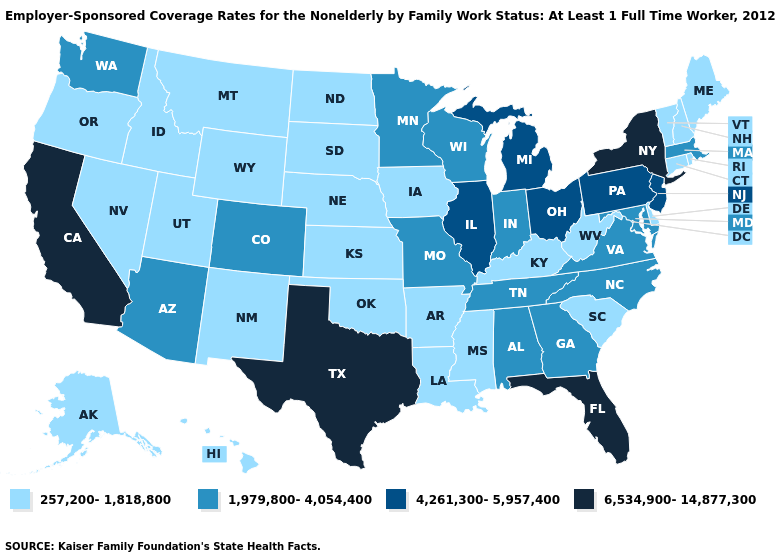Does Hawaii have the lowest value in the USA?
Give a very brief answer. Yes. Does Pennsylvania have the lowest value in the USA?
Be succinct. No. Does Florida have the lowest value in the USA?
Short answer required. No. Name the states that have a value in the range 6,534,900-14,877,300?
Answer briefly. California, Florida, New York, Texas. What is the lowest value in states that border West Virginia?
Short answer required. 257,200-1,818,800. Does the map have missing data?
Short answer required. No. What is the value of Arkansas?
Concise answer only. 257,200-1,818,800. What is the highest value in the Northeast ?
Be succinct. 6,534,900-14,877,300. Is the legend a continuous bar?
Short answer required. No. What is the value of Kansas?
Concise answer only. 257,200-1,818,800. Does Iowa have the lowest value in the MidWest?
Short answer required. Yes. Which states have the lowest value in the South?
Be succinct. Arkansas, Delaware, Kentucky, Louisiana, Mississippi, Oklahoma, South Carolina, West Virginia. Which states hav the highest value in the Northeast?
Give a very brief answer. New York. What is the lowest value in the USA?
Write a very short answer. 257,200-1,818,800. Does Indiana have a lower value than Michigan?
Write a very short answer. Yes. 